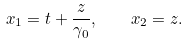<formula> <loc_0><loc_0><loc_500><loc_500>x _ { 1 } = t + \frac { z } { \gamma _ { 0 } } , \quad x _ { 2 } = z .</formula> 